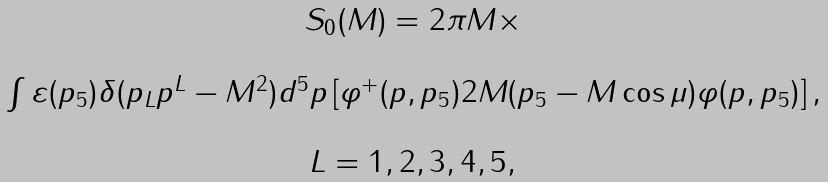<formula> <loc_0><loc_0><loc_500><loc_500>\begin{array} { c } S _ { 0 } ( M ) = 2 \pi M \times \\ \\ \int \varepsilon ( p _ { 5 } ) \delta ( p _ { L } p ^ { L } - M ^ { 2 } ) d ^ { 5 } p \left [ \varphi ^ { + } ( p , p _ { 5 } ) 2 M ( p _ { 5 } - M \cos \mu ) \varphi ( p , p _ { 5 } ) \right ] , \\ \\ L = 1 , 2 , 3 , 4 , 5 , \end{array}</formula> 